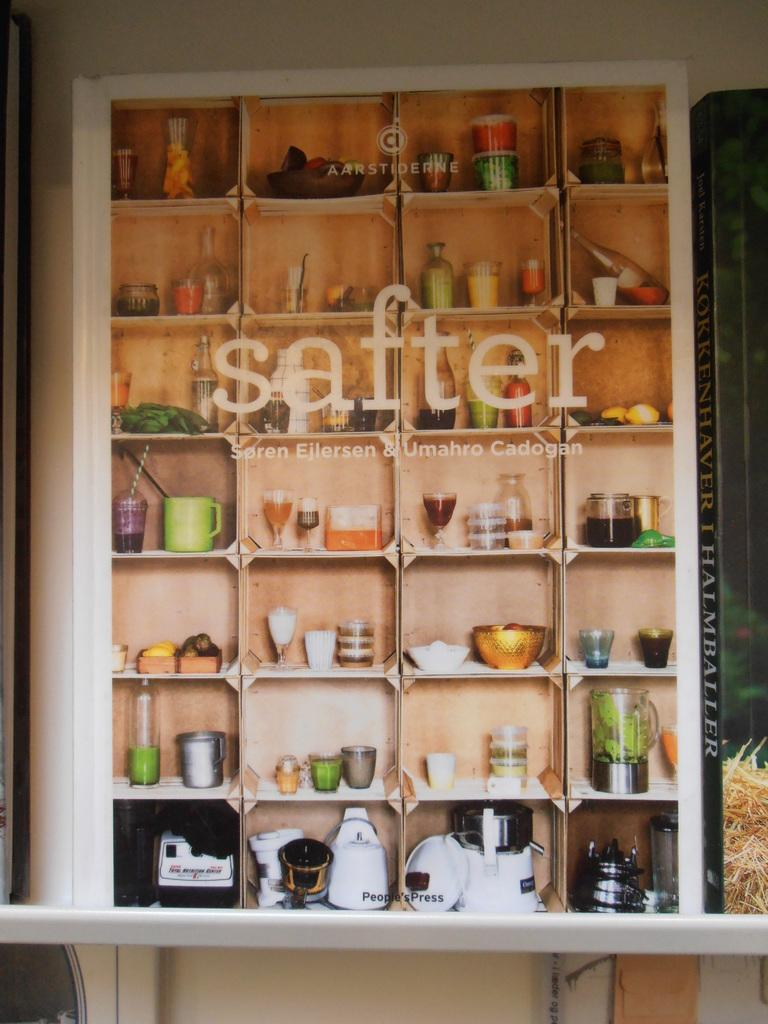<image>
Offer a succinct explanation of the picture presented. A bunch of small objects are on display behind a glass that has the word safter displayed. 